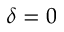Convert formula to latex. <formula><loc_0><loc_0><loc_500><loc_500>\delta = 0</formula> 